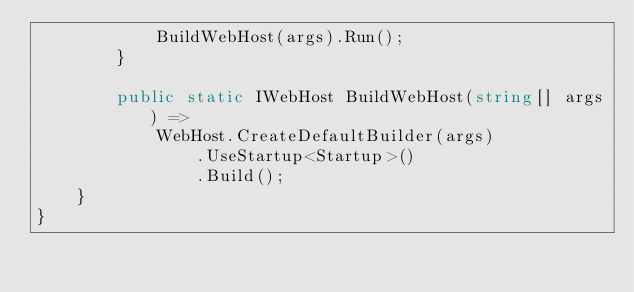<code> <loc_0><loc_0><loc_500><loc_500><_C#_>            BuildWebHost(args).Run();
        }

        public static IWebHost BuildWebHost(string[] args) =>
            WebHost.CreateDefaultBuilder(args)
                .UseStartup<Startup>()
                .Build();
    }
}
</code> 